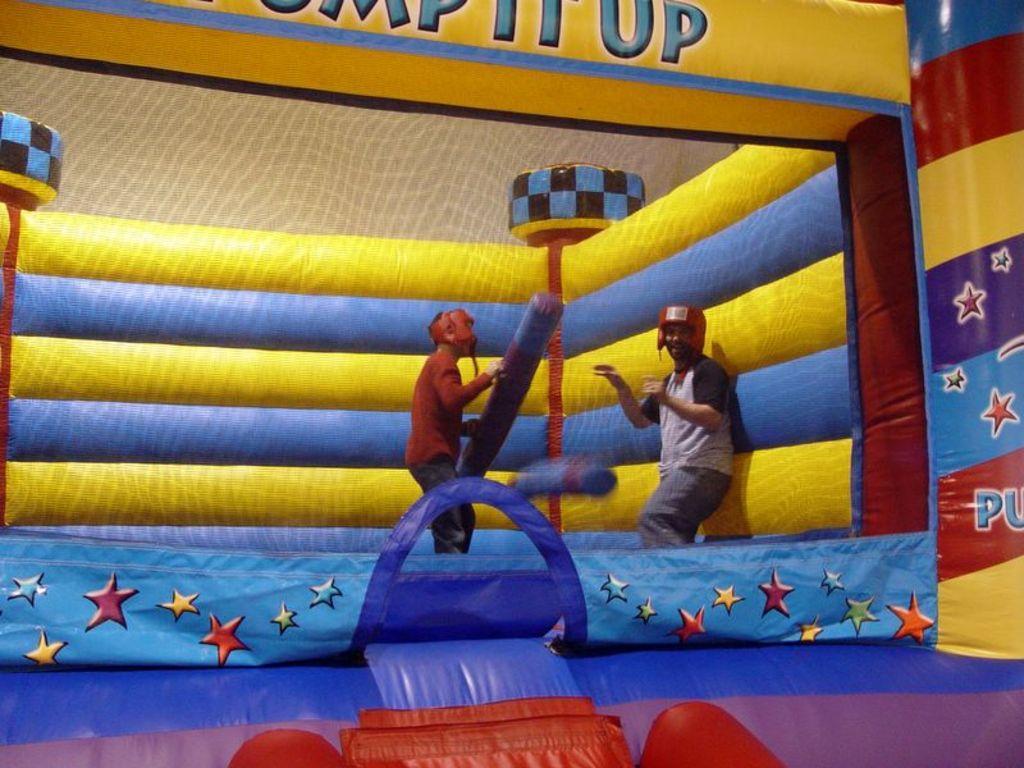Can you describe this image briefly? In this image we can see two persons are standing on an inflatable object and a person among them is holding an object in the hands. 